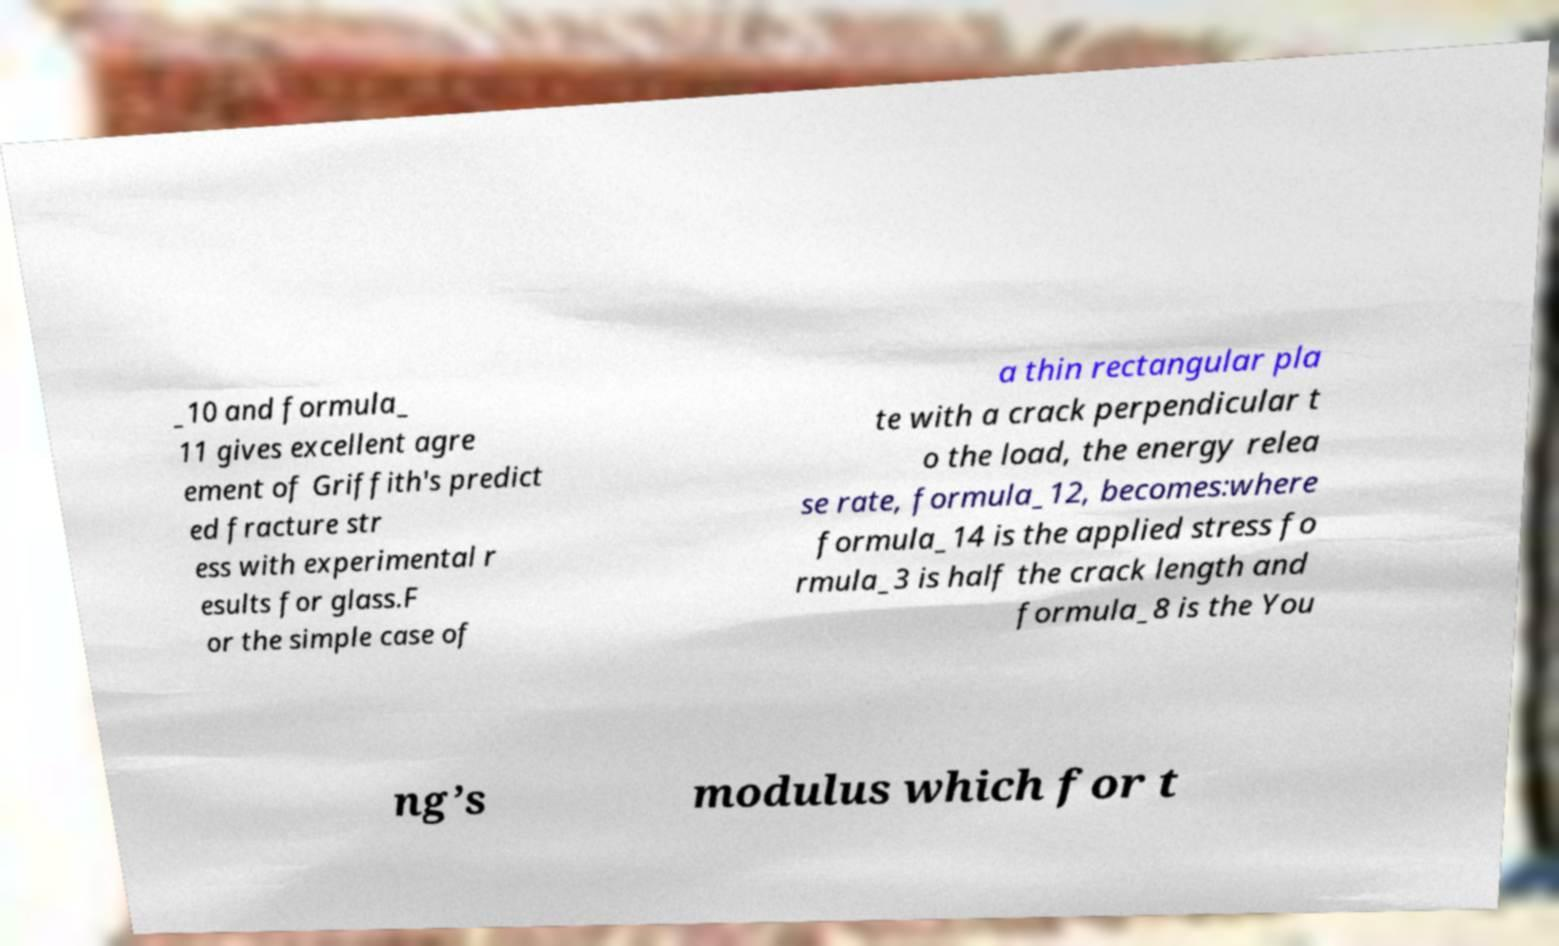There's text embedded in this image that I need extracted. Can you transcribe it verbatim? _10 and formula_ 11 gives excellent agre ement of Griffith's predict ed fracture str ess with experimental r esults for glass.F or the simple case of a thin rectangular pla te with a crack perpendicular t o the load, the energy relea se rate, formula_12, becomes:where formula_14 is the applied stress fo rmula_3 is half the crack length and formula_8 is the You ng’s modulus which for t 